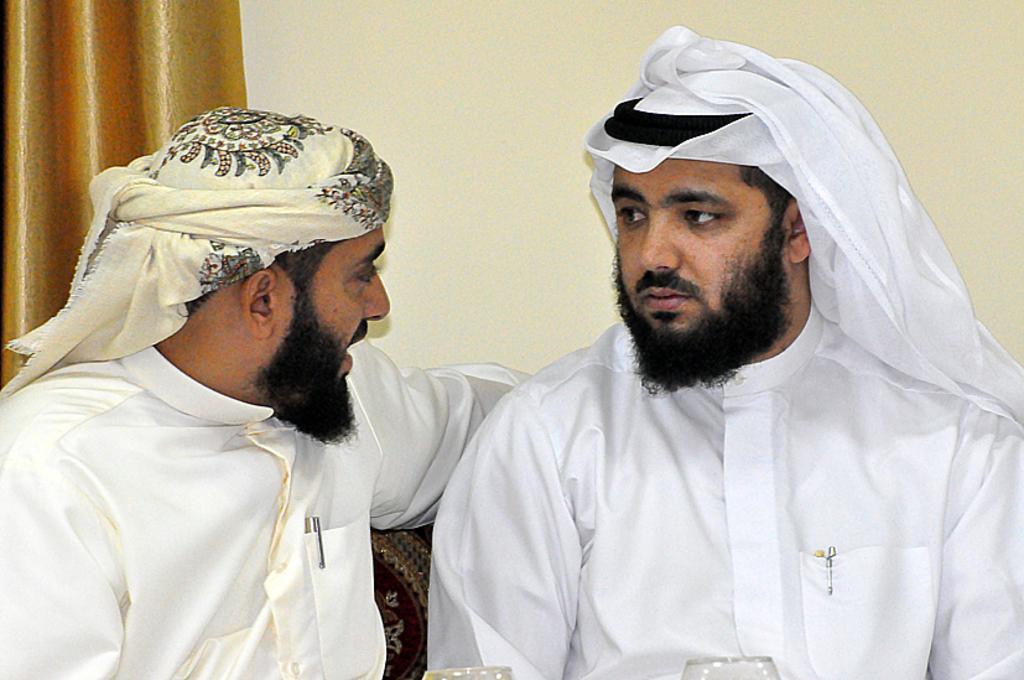In one or two sentences, can you explain what this image depicts? In the center of the image we can see men are sitting on a couch and wearing the white dresses and tying a clothes to their heads. In the background of the image we can see the wall. At the bottom of the image we can see the glasses. 